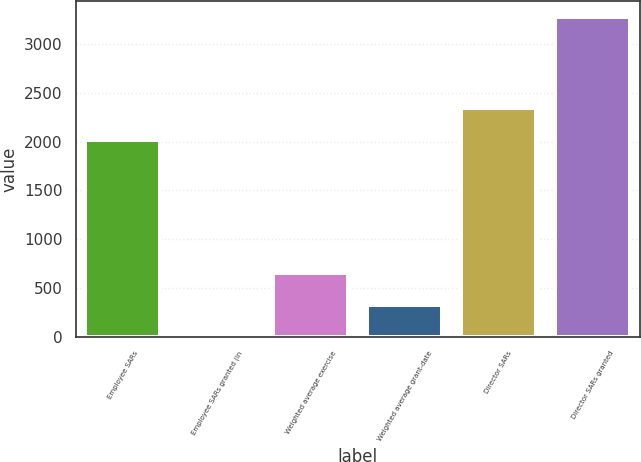<chart> <loc_0><loc_0><loc_500><loc_500><bar_chart><fcel>Employee SARs<fcel>Employee SARs granted (in<fcel>Weighted average exercise<fcel>Weighted average grant-date<fcel>Director SARs<fcel>Director SARs granted<nl><fcel>2014<fcel>0.3<fcel>655.64<fcel>327.97<fcel>2341.67<fcel>3277<nl></chart> 